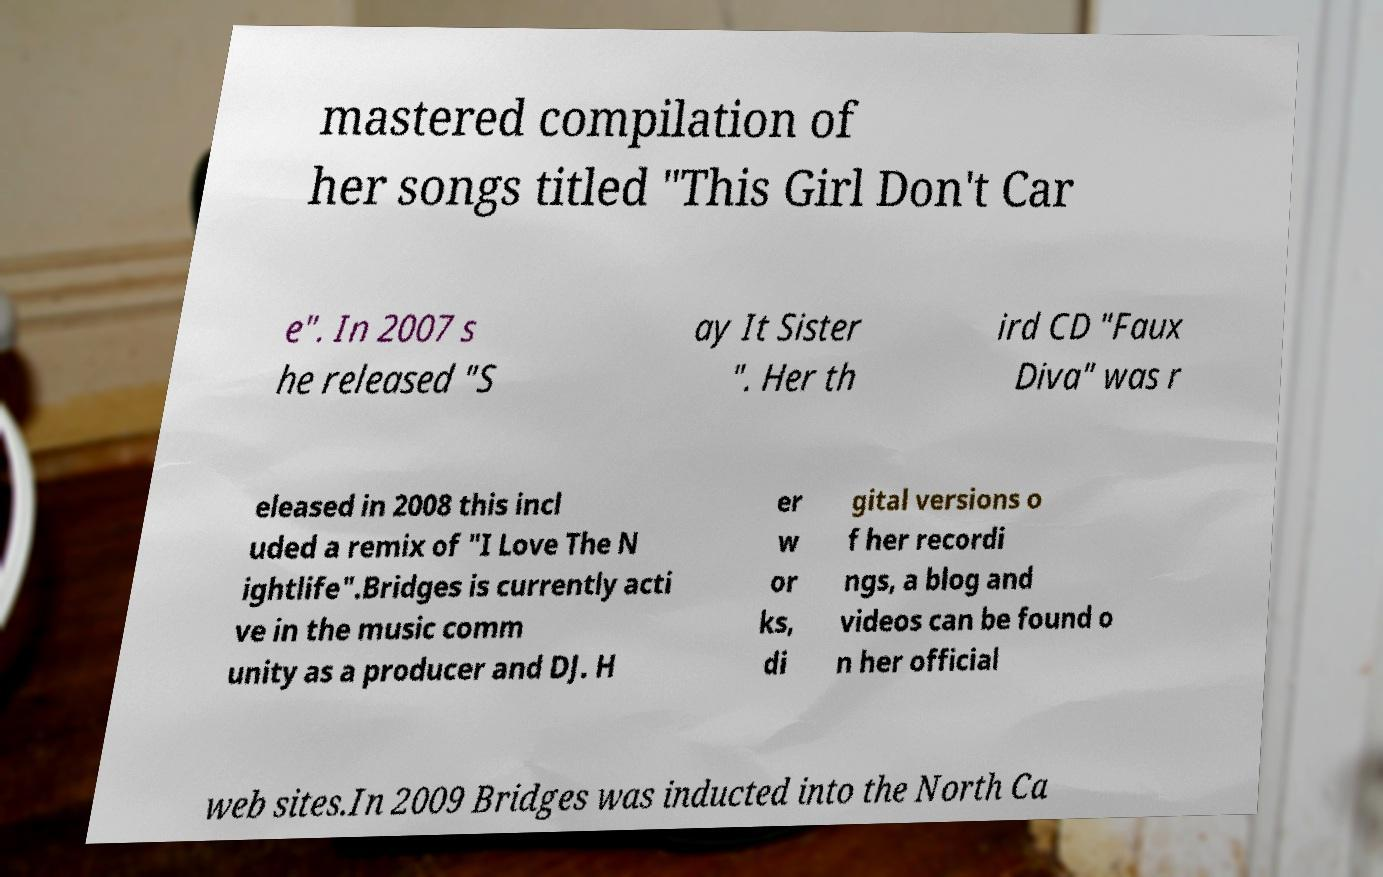Could you extract and type out the text from this image? mastered compilation of her songs titled "This Girl Don't Car e". In 2007 s he released "S ay It Sister ". Her th ird CD "Faux Diva" was r eleased in 2008 this incl uded a remix of "I Love The N ightlife".Bridges is currently acti ve in the music comm unity as a producer and DJ. H er w or ks, di gital versions o f her recordi ngs, a blog and videos can be found o n her official web sites.In 2009 Bridges was inducted into the North Ca 